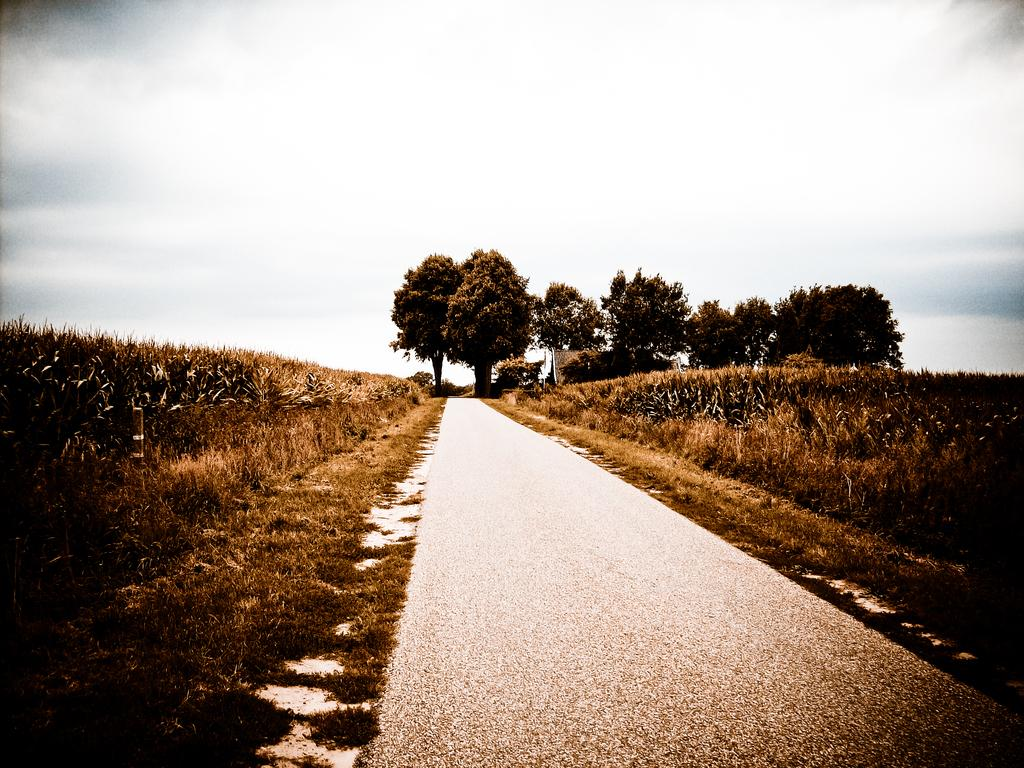What type of vegetation can be seen in the image? There are trees and dry plants in the image. What else is present in the image besides vegetation? There is a road in the image. What is the color of the sky in the image? The sky is blue and white in color. Where is the cub playing with the potato near the lake in the image? There is no cub, potato, or lake present in the image. 